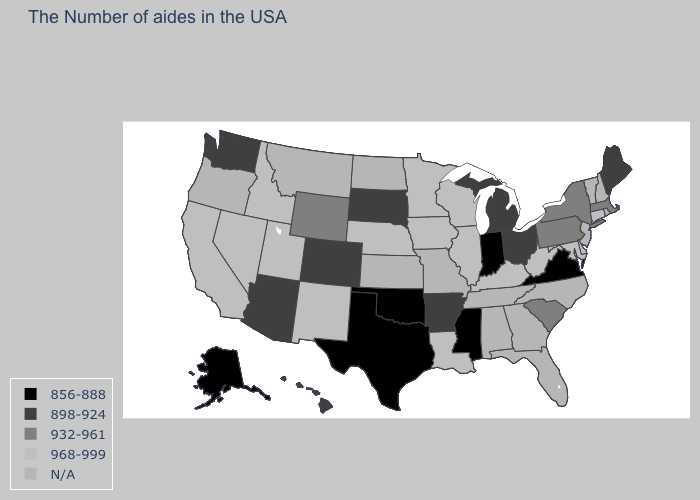What is the value of Nevada?
Write a very short answer. 968-999. Does Delaware have the highest value in the USA?
Quick response, please. Yes. What is the value of Indiana?
Write a very short answer. 856-888. What is the value of Georgia?
Give a very brief answer. N/A. Does California have the highest value in the USA?
Answer briefly. Yes. Does Oklahoma have the lowest value in the USA?
Give a very brief answer. Yes. What is the highest value in the USA?
Give a very brief answer. 968-999. Among the states that border Rhode Island , does Connecticut have the lowest value?
Keep it brief. No. Name the states that have a value in the range 932-961?
Be succinct. Massachusetts, New York, Pennsylvania, South Carolina, Wyoming. What is the value of Alabama?
Write a very short answer. N/A. Does Wisconsin have the lowest value in the MidWest?
Give a very brief answer. No. Does the first symbol in the legend represent the smallest category?
Keep it brief. Yes. What is the highest value in the USA?
Short answer required. 968-999. What is the value of New Mexico?
Be succinct. 968-999. 